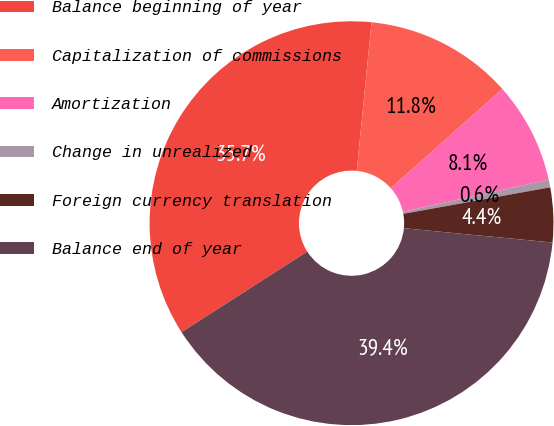<chart> <loc_0><loc_0><loc_500><loc_500><pie_chart><fcel>Balance beginning of year<fcel>Capitalization of commissions<fcel>Amortization<fcel>Change in unrealized<fcel>Foreign currency translation<fcel>Balance end of year<nl><fcel>35.66%<fcel>11.85%<fcel>8.11%<fcel>0.62%<fcel>4.37%<fcel>39.4%<nl></chart> 